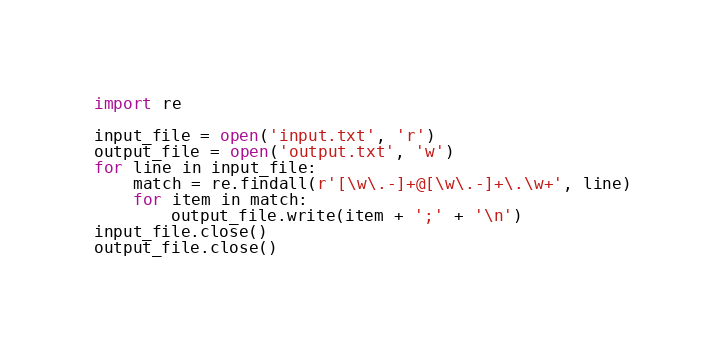<code> <loc_0><loc_0><loc_500><loc_500><_Python_>import re

input_file = open('input.txt', 'r')
output_file = open('output.txt', 'w')
for line in input_file:
    match = re.findall(r'[\w\.-]+@[\w\.-]+\.\w+', line)
    for item in match:
        output_file.write(item + ';' + '\n')
input_file.close()
output_file.close()

</code> 